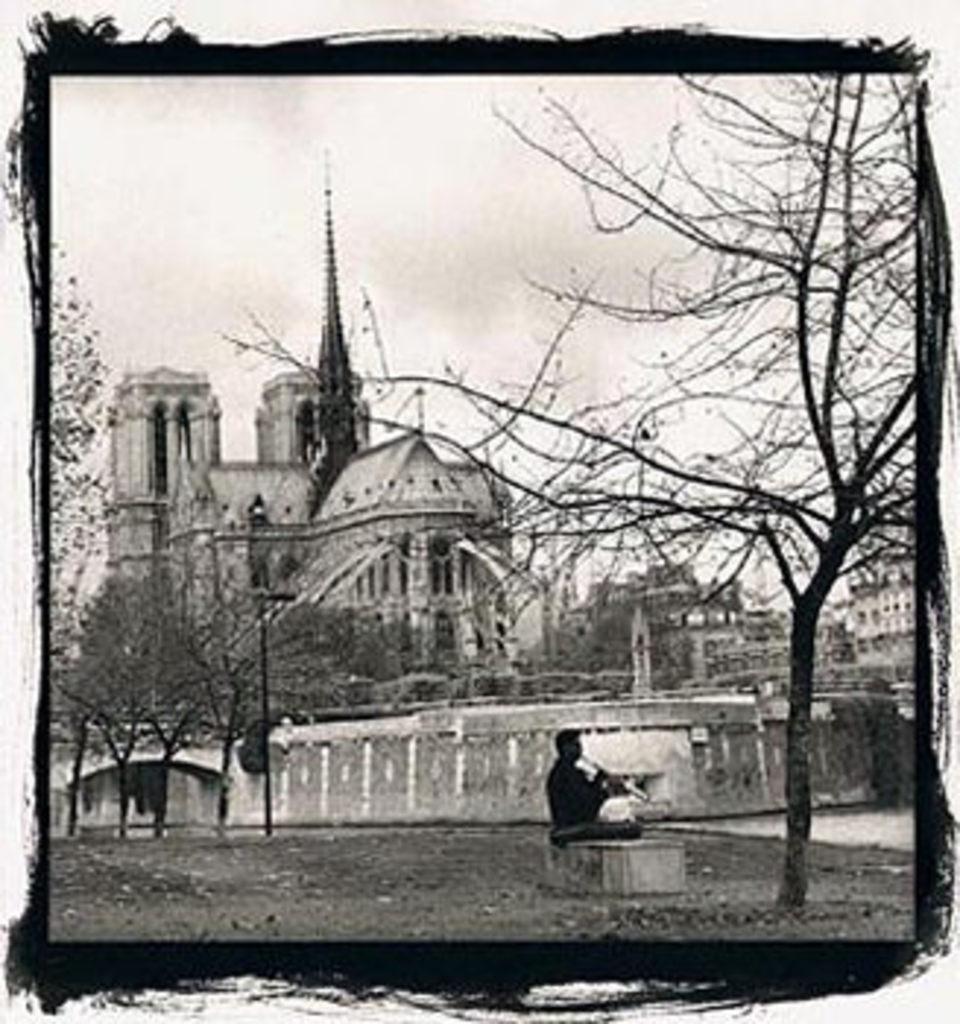Describe this image in one or two sentences. In this picture we can see a person sitting on a path and in the background we can see buildings,trees. 